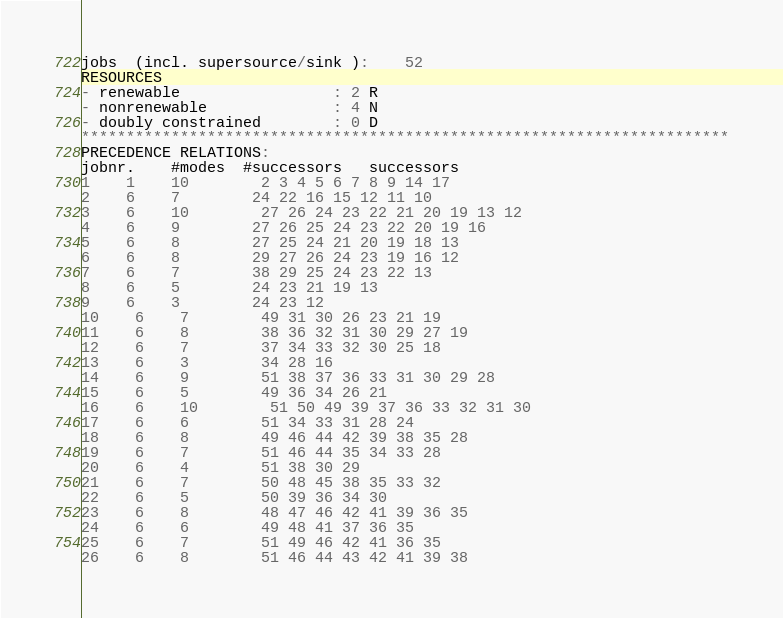<code> <loc_0><loc_0><loc_500><loc_500><_ObjectiveC_>jobs  (incl. supersource/sink ):	52
RESOURCES
- renewable                 : 2 R
- nonrenewable              : 4 N
- doubly constrained        : 0 D
************************************************************************
PRECEDENCE RELATIONS:
jobnr.    #modes  #successors   successors
1	1	10		2 3 4 5 6 7 8 9 14 17 
2	6	7		24 22 16 15 12 11 10 
3	6	10		27 26 24 23 22 21 20 19 13 12 
4	6	9		27 26 25 24 23 22 20 19 16 
5	6	8		27 25 24 21 20 19 18 13 
6	6	8		29 27 26 24 23 19 16 12 
7	6	7		38 29 25 24 23 22 13 
8	6	5		24 23 21 19 13 
9	6	3		24 23 12 
10	6	7		49 31 30 26 23 21 19 
11	6	8		38 36 32 31 30 29 27 19 
12	6	7		37 34 33 32 30 25 18 
13	6	3		34 28 16 
14	6	9		51 38 37 36 33 31 30 29 28 
15	6	5		49 36 34 26 21 
16	6	10		51 50 49 39 37 36 33 32 31 30 
17	6	6		51 34 33 31 28 24 
18	6	8		49 46 44 42 39 38 35 28 
19	6	7		51 46 44 35 34 33 28 
20	6	4		51 38 30 29 
21	6	7		50 48 45 38 35 33 32 
22	6	5		50 39 36 34 30 
23	6	8		48 47 46 42 41 39 36 35 
24	6	6		49 48 41 37 36 35 
25	6	7		51 49 46 42 41 36 35 
26	6	8		51 46 44 43 42 41 39 38 </code> 